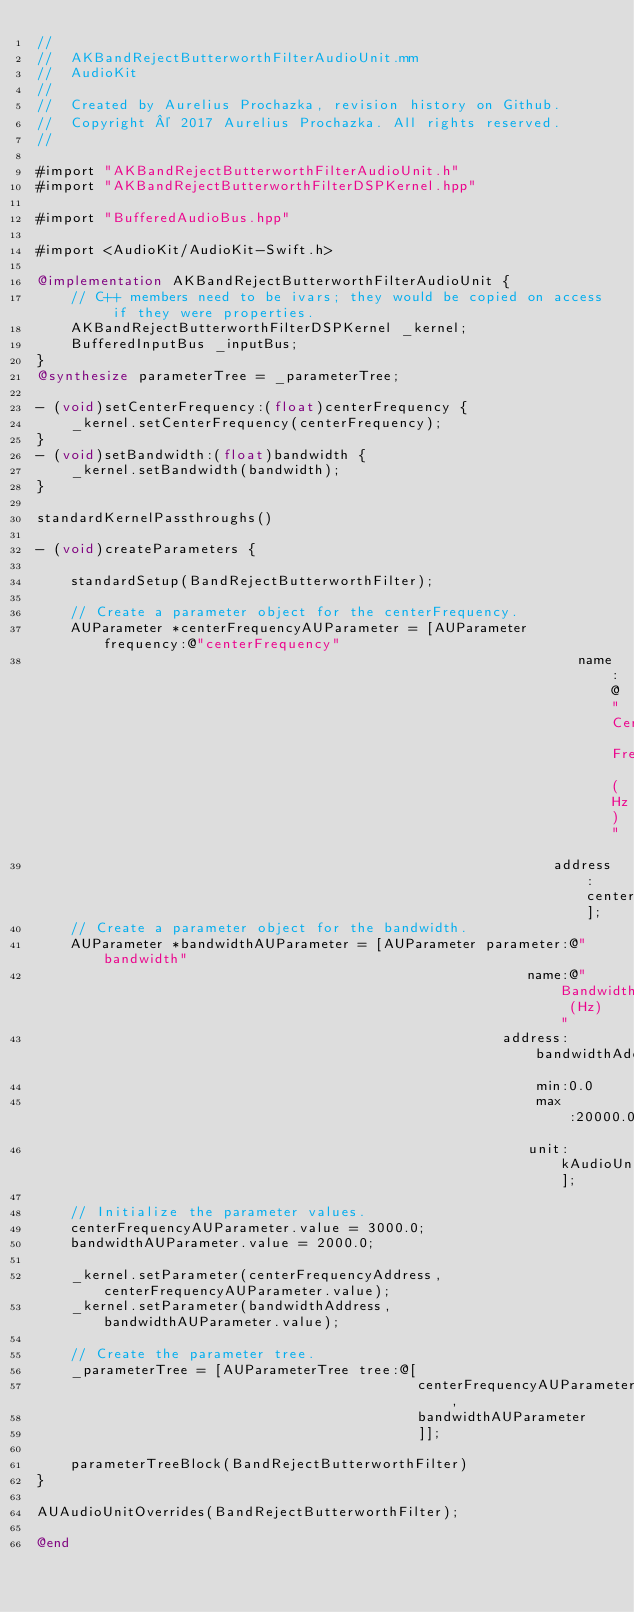Convert code to text. <code><loc_0><loc_0><loc_500><loc_500><_ObjectiveC_>//
//  AKBandRejectButterworthFilterAudioUnit.mm
//  AudioKit
//
//  Created by Aurelius Prochazka, revision history on Github.
//  Copyright © 2017 Aurelius Prochazka. All rights reserved.
//

#import "AKBandRejectButterworthFilterAudioUnit.h"
#import "AKBandRejectButterworthFilterDSPKernel.hpp"

#import "BufferedAudioBus.hpp"

#import <AudioKit/AudioKit-Swift.h>

@implementation AKBandRejectButterworthFilterAudioUnit {
    // C++ members need to be ivars; they would be copied on access if they were properties.
    AKBandRejectButterworthFilterDSPKernel _kernel;
    BufferedInputBus _inputBus;
}
@synthesize parameterTree = _parameterTree;

- (void)setCenterFrequency:(float)centerFrequency {
    _kernel.setCenterFrequency(centerFrequency);
}
- (void)setBandwidth:(float)bandwidth {
    _kernel.setBandwidth(bandwidth);
}

standardKernelPassthroughs()

- (void)createParameters {
    
    standardSetup(BandRejectButterworthFilter);
    
    // Create a parameter object for the centerFrequency.
    AUParameter *centerFrequencyAUParameter = [AUParameter frequency:@"centerFrequency"
                                                                name:@"Center Frequency (Hz)"
                                                             address:centerFrequencyAddress];
    // Create a parameter object for the bandwidth.
    AUParameter *bandwidthAUParameter = [AUParameter parameter:@"bandwidth"
                                                          name:@"Bandwidth (Hz)"
                                                       address:bandwidthAddress
                                                           min:0.0
                                                           max:20000.0
                                                          unit:kAudioUnitParameterUnit_Hertz];
    
    // Initialize the parameter values.
    centerFrequencyAUParameter.value = 3000.0;
    bandwidthAUParameter.value = 2000.0;
    
    _kernel.setParameter(centerFrequencyAddress, centerFrequencyAUParameter.value);
    _kernel.setParameter(bandwidthAddress,       bandwidthAUParameter.value);
    
    // Create the parameter tree.
    _parameterTree = [AUParameterTree tree:@[
                                             centerFrequencyAUParameter,
                                             bandwidthAUParameter
                                             ]];
    
    parameterTreeBlock(BandRejectButterworthFilter)
}

AUAudioUnitOverrides(BandRejectButterworthFilter);

@end


</code> 